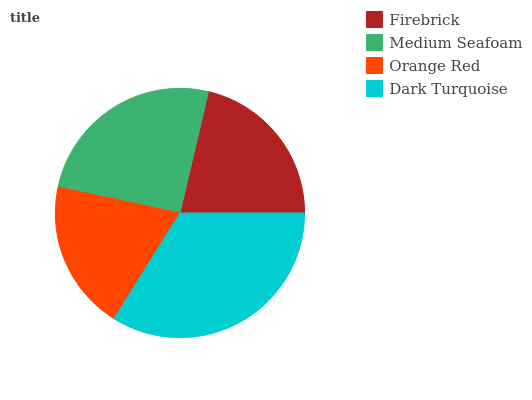Is Orange Red the minimum?
Answer yes or no. Yes. Is Dark Turquoise the maximum?
Answer yes or no. Yes. Is Medium Seafoam the minimum?
Answer yes or no. No. Is Medium Seafoam the maximum?
Answer yes or no. No. Is Medium Seafoam greater than Firebrick?
Answer yes or no. Yes. Is Firebrick less than Medium Seafoam?
Answer yes or no. Yes. Is Firebrick greater than Medium Seafoam?
Answer yes or no. No. Is Medium Seafoam less than Firebrick?
Answer yes or no. No. Is Medium Seafoam the high median?
Answer yes or no. Yes. Is Firebrick the low median?
Answer yes or no. Yes. Is Dark Turquoise the high median?
Answer yes or no. No. Is Orange Red the low median?
Answer yes or no. No. 